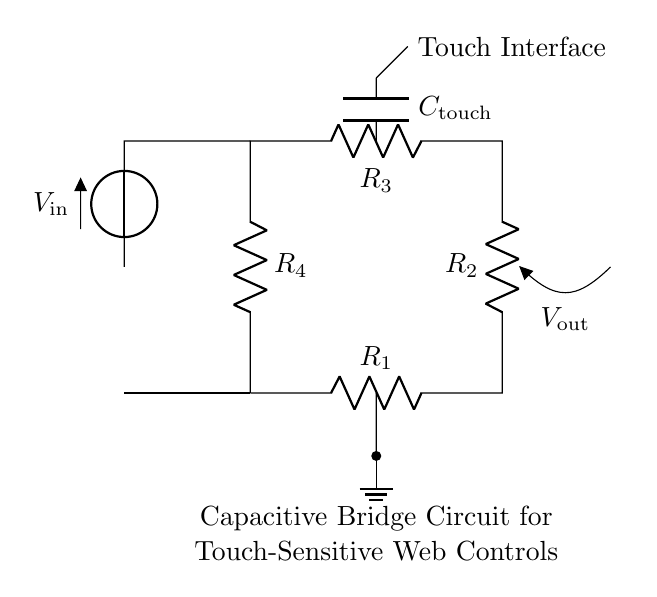What is the type of circuit shown? The circuit is a capacitive bridge circuit, designed for touch-sensitive applications. This is determined by the presence of capacitors and the bridge configuration that allows for sensitivity in detecting touch inputs.
Answer: capacitive bridge How many resistors are in the circuit? There are four resistors present in the circuit as indicated by the labels R1, R2, R3, and R4, which form the bridge configuration to compare the two branches for sensitivity changes.
Answer: four What is the role of C_touch in this circuit? The capacitor C_touch serves as the touch interface sensor, enabling the circuit to detect touch or capacitance changes when interacted with, which is critical for the application in web controls.
Answer: touch sensor What is the voltage source labeled as? The voltage source is labeled as V_in, indicating that it is the input voltage supplying power across the capacitive bridge circuit. This is shown left of the resistors and connected to the top node of the bridge.
Answer: V_in What happens to V_out with fluctuating capacitance? The output voltage, V_out, experiences variations in response to changes in the capacitance at C_touch. This fluctuation is due to the principle of the bridge balancing, where any change alters the voltage output reflecting the touch or interaction detected.
Answer: varies What is connected to the ground in this circuit? The ground connection is part of the circuit and is connected to the lower node of the circuit, specifically at the midpoint between the resistors and touching the base of the bridge for a common reference point.
Answer: ground What can this circuit be used for? This circuit can be used for touch-sensitive controls in web applications enabling users to interact with a web interface through physical touch or proximity, enhancing the user experience.
Answer: touch-sensitive controls 